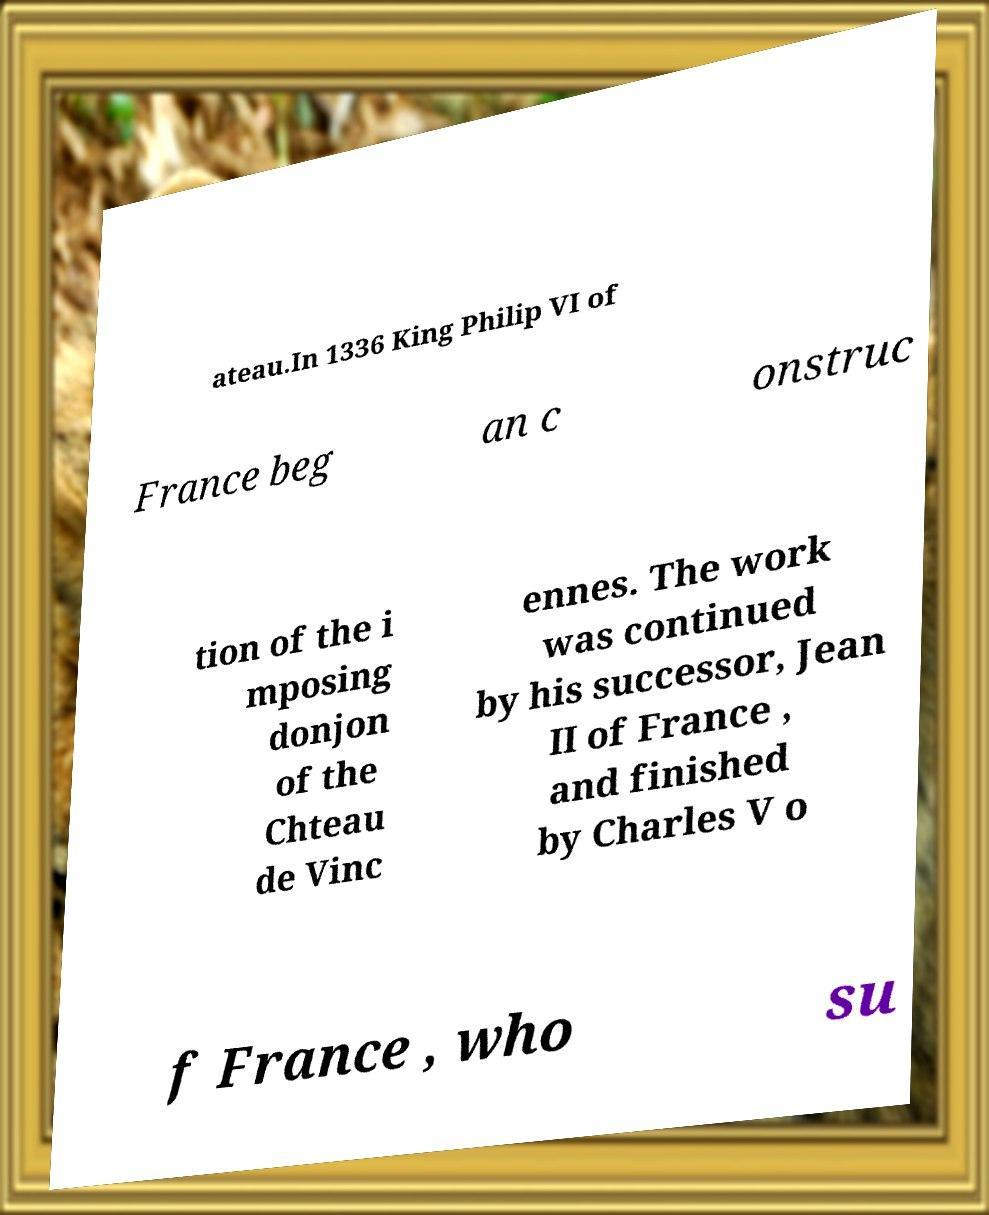For documentation purposes, I need the text within this image transcribed. Could you provide that? ateau.In 1336 King Philip VI of France beg an c onstruc tion of the i mposing donjon of the Chteau de Vinc ennes. The work was continued by his successor, Jean II of France , and finished by Charles V o f France , who su 